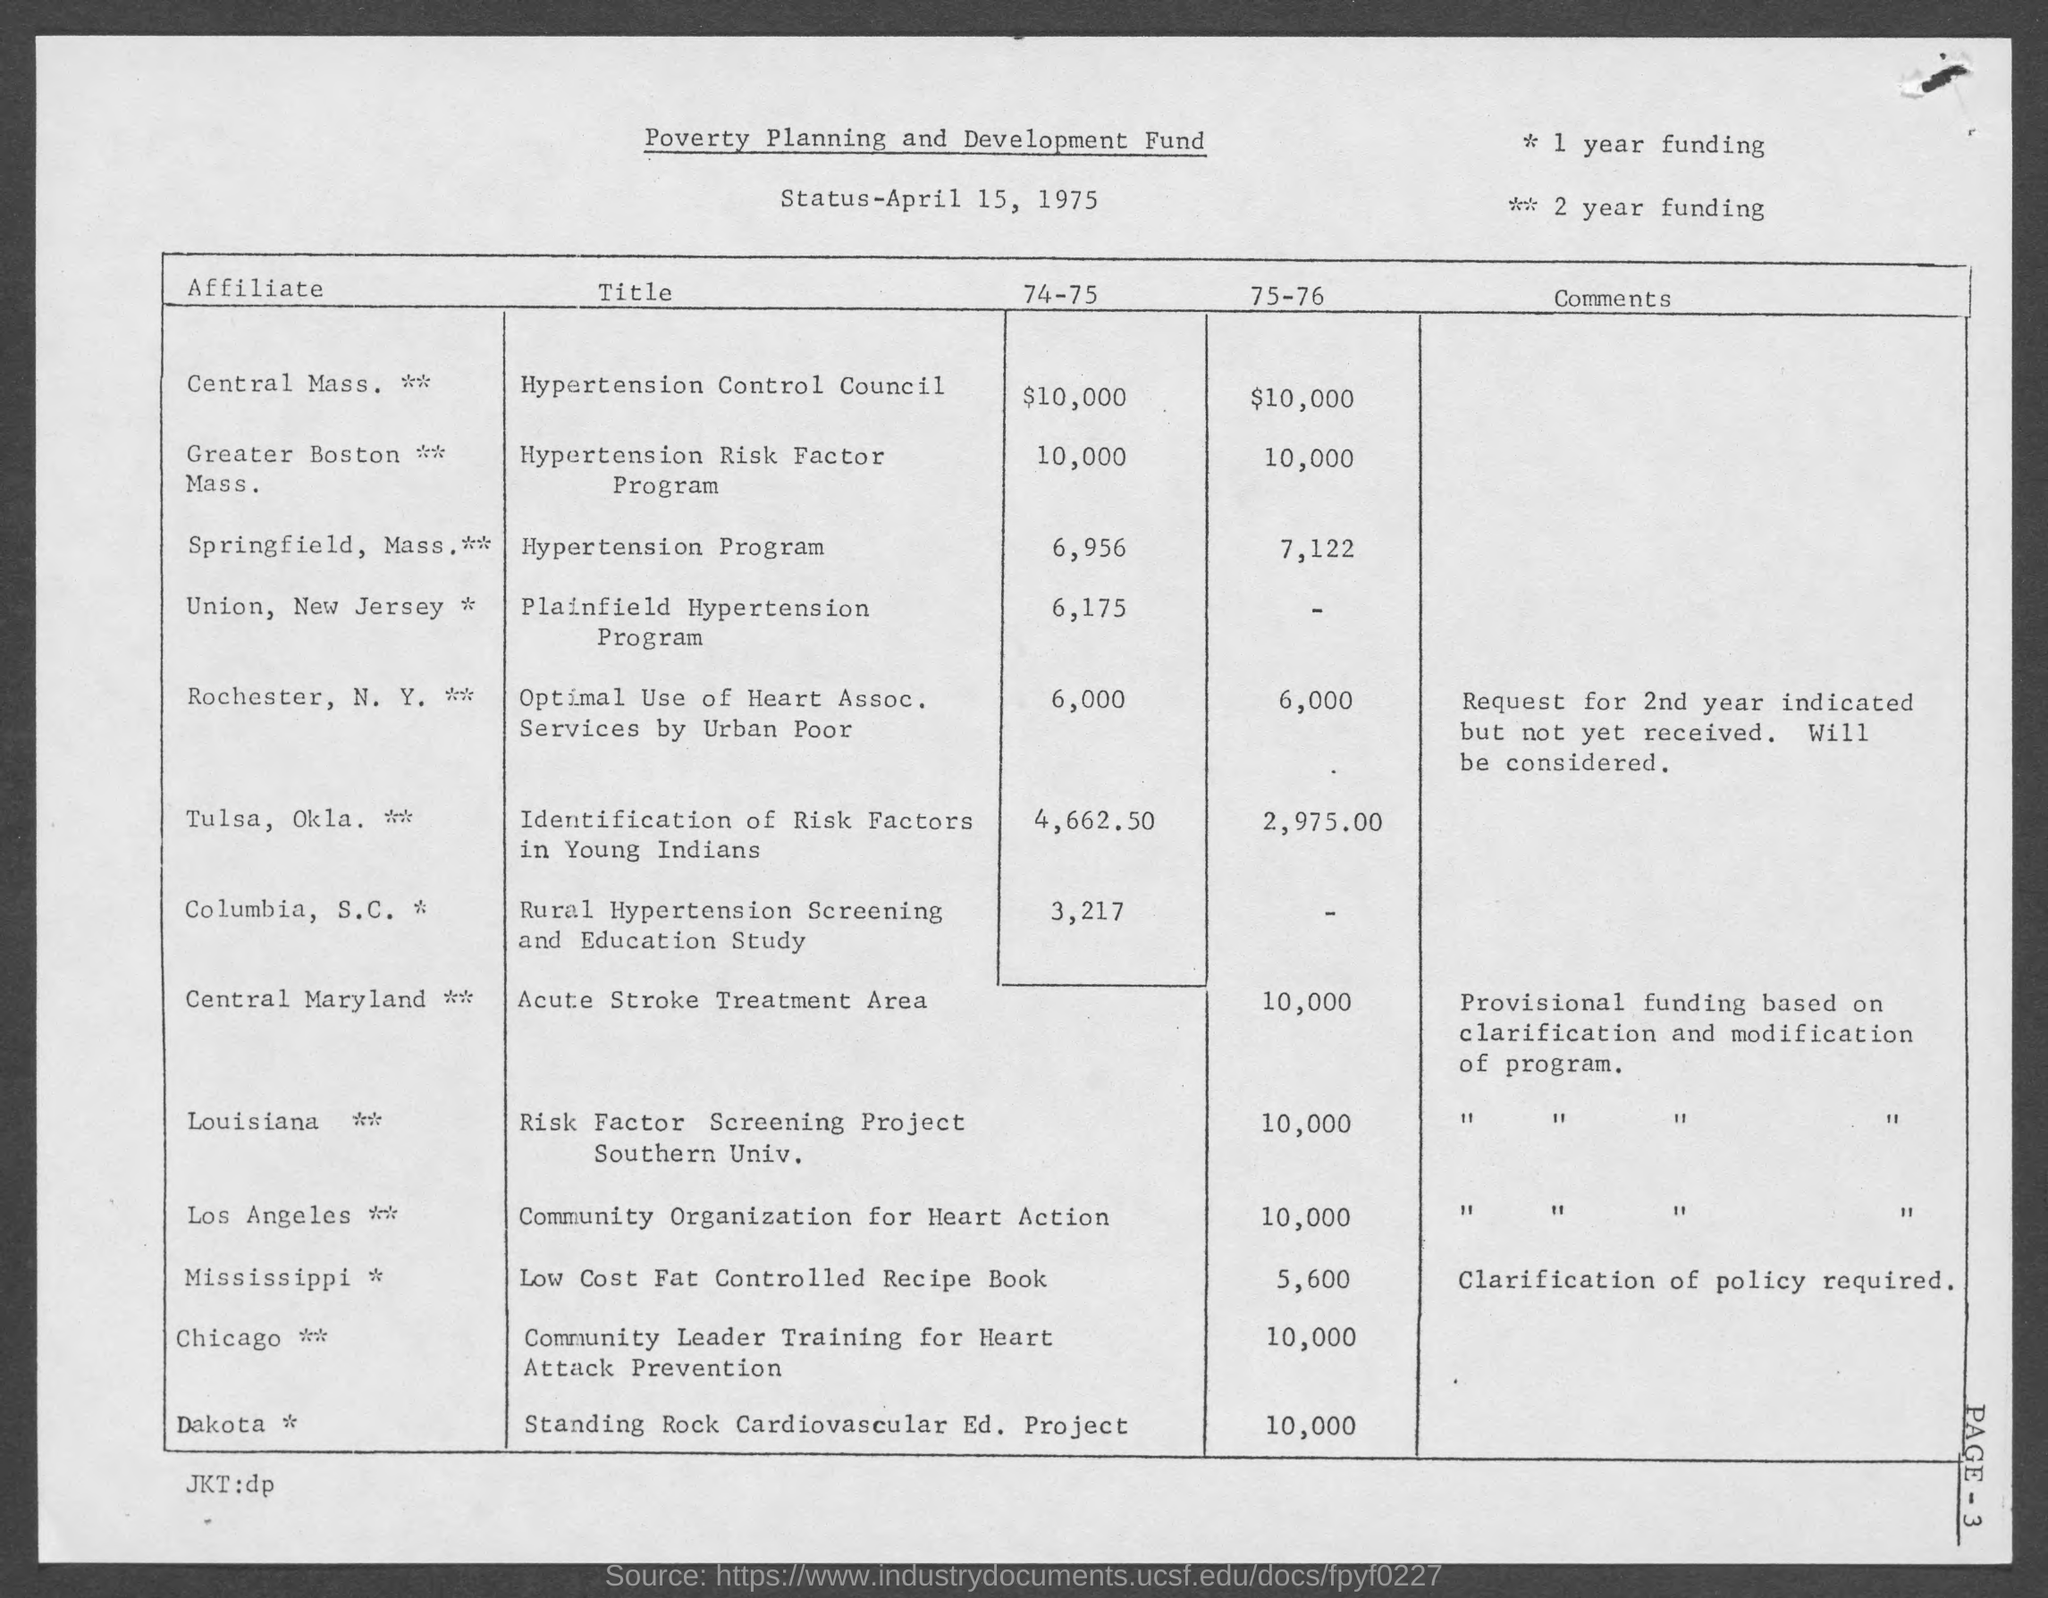Point out several critical features in this image. The date mentioned in this document is April 15, 1975. 